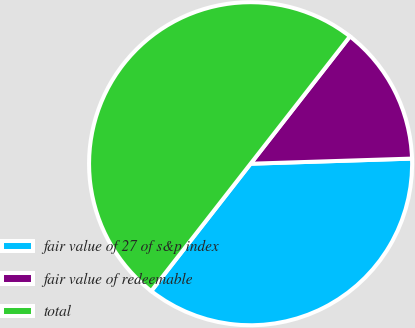<chart> <loc_0><loc_0><loc_500><loc_500><pie_chart><fcel>fair value of 27 of s&p index<fcel>fair value of redeemable<fcel>total<nl><fcel>36.05%<fcel>13.95%<fcel>50.0%<nl></chart> 